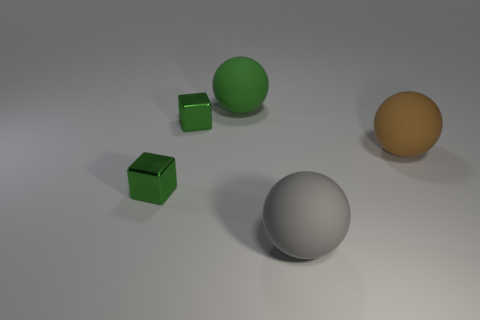There is a tiny thing in front of the large brown rubber ball; what is its color?
Provide a succinct answer. Green. Do the brown object and the green sphere have the same size?
Offer a very short reply. Yes. What is the size of the thing that is on the left side of the green ball and in front of the brown sphere?
Provide a short and direct response. Small. How many cubes have the same material as the brown ball?
Your answer should be compact. 0. There is a rubber object that is left of the gray sphere; is its shape the same as the big gray rubber object?
Your response must be concise. Yes. What number of objects are either large balls right of the large green object or small green metal cubes?
Keep it short and to the point. 4. Are there any cyan matte things of the same shape as the large brown object?
Your answer should be very brief. No. What shape is the gray thing that is the same size as the green rubber object?
Your response must be concise. Sphere. What shape is the tiny metallic object that is behind the small block that is to the left of the shiny cube that is behind the large brown object?
Ensure brevity in your answer.  Cube. There is a brown thing; does it have the same shape as the green metallic object that is behind the brown rubber ball?
Provide a short and direct response. No. 